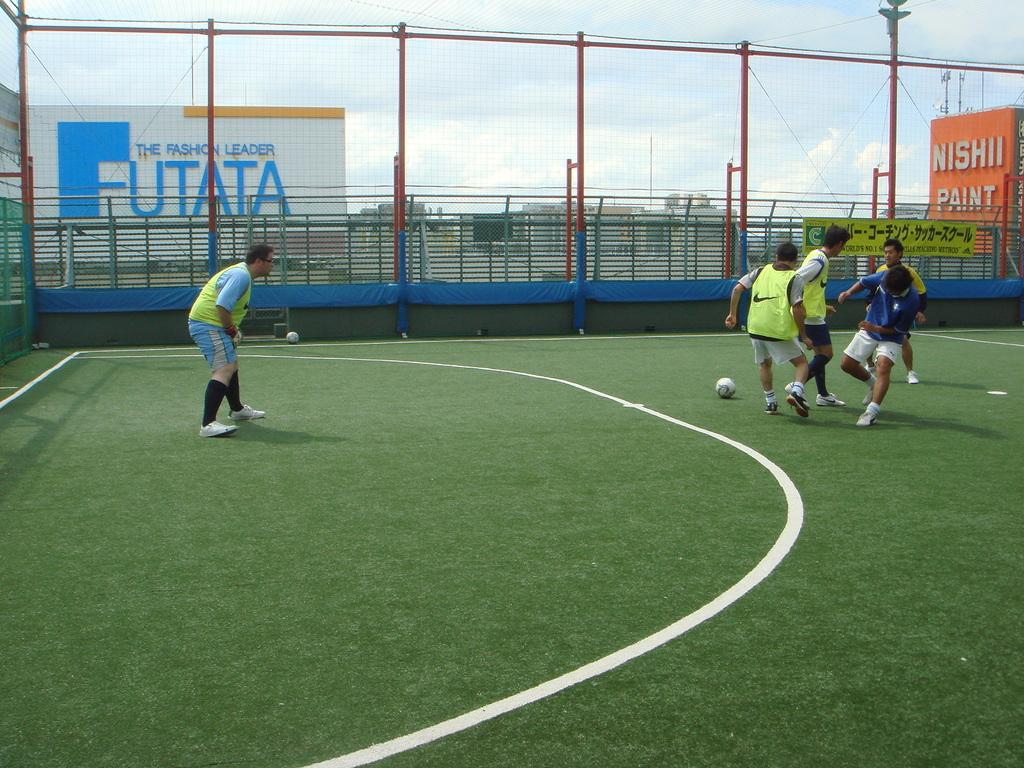Provide a one-sentence caption for the provided image. A group of men playing soccer on a fake turf field at the top of a building near a Nishii Paint sign and a Futata billboard. 